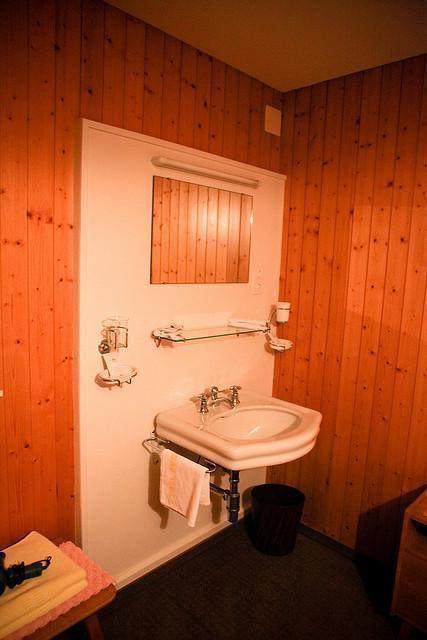How many giraffes are not reaching towards the woman?
Give a very brief answer. 0. 